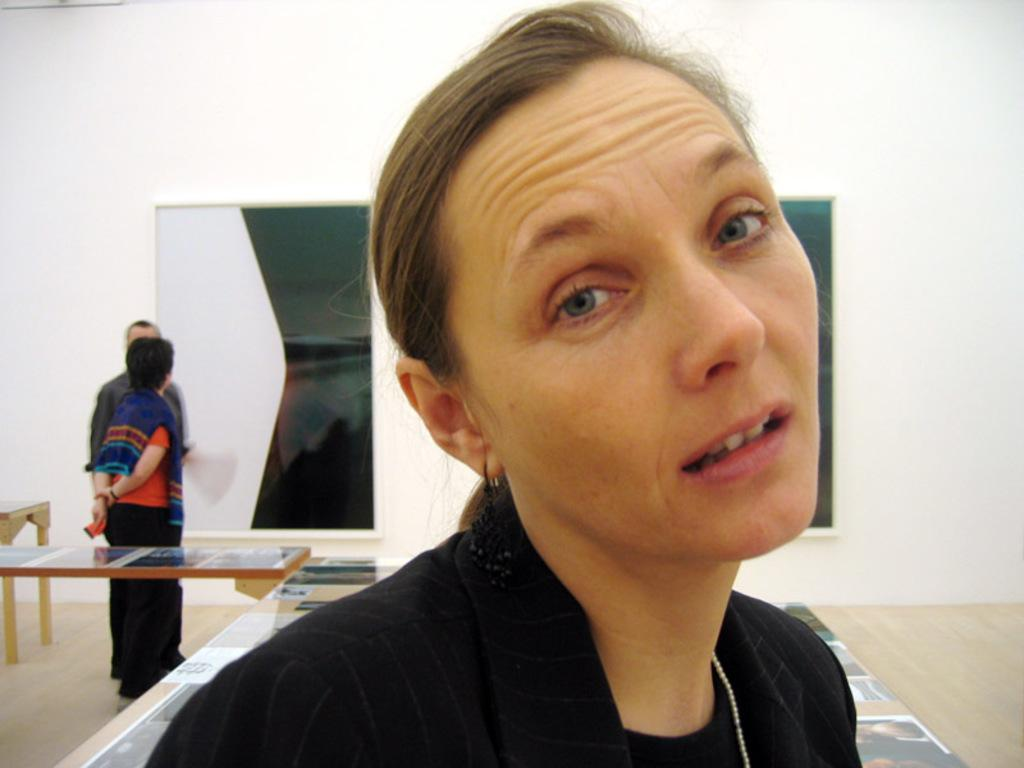Who is the main subject in the image? There is a woman in the image. What is the woman doing in the image? The woman is posing. Are there any other people in the image besides the woman? Yes, there are people standing in the image. What objects can be seen on the tables in the image? Pictures are present on the tables. What type of breakfast is being served on the tables in the image? There is no breakfast present in the image; it only features people standing and pictures on the tables. 